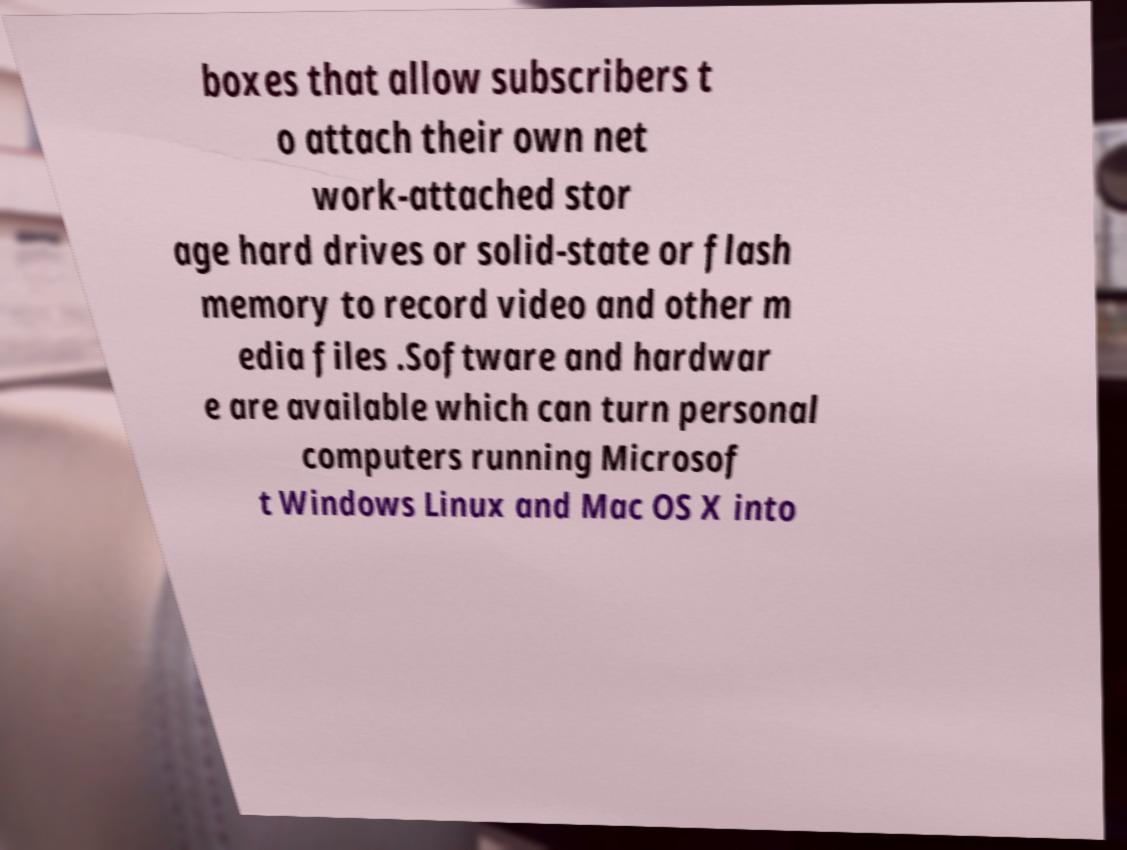Please identify and transcribe the text found in this image. boxes that allow subscribers t o attach their own net work-attached stor age hard drives or solid-state or flash memory to record video and other m edia files .Software and hardwar e are available which can turn personal computers running Microsof t Windows Linux and Mac OS X into 